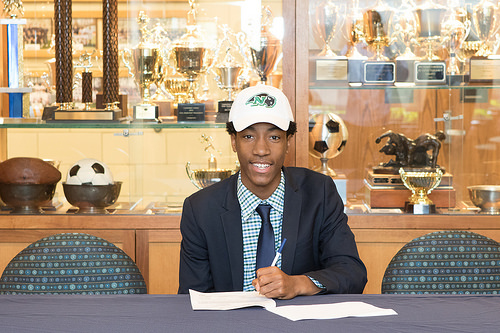<image>
Is there a man behind the ball? No. The man is not behind the ball. From this viewpoint, the man appears to be positioned elsewhere in the scene. Where is the ball in relation to the cap? Is it next to the cap? Yes. The ball is positioned adjacent to the cap, located nearby in the same general area. Where is the chair in relation to the boy? Is it next to the boy? Yes. The chair is positioned adjacent to the boy, located nearby in the same general area. 